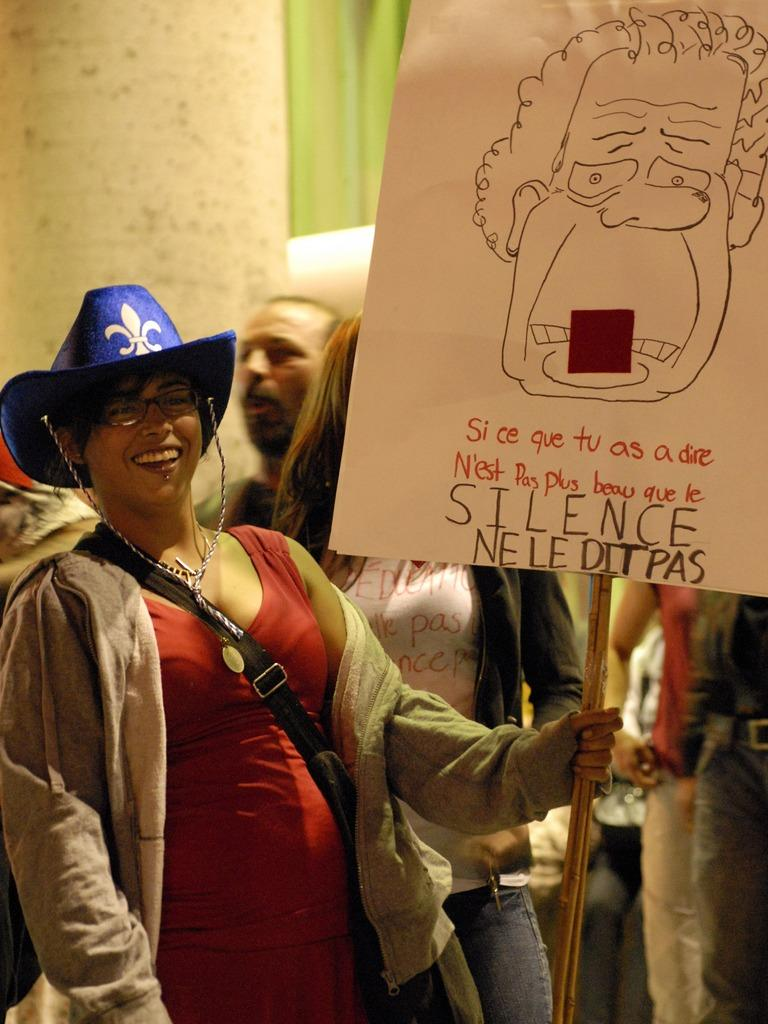How many people are in the image? There is a group of people in the image. What is the woman holding in the image? The woman is holding a banner in the image. What is the expression on the woman's face? The woman is smiling in the image. What can be seen in the background of the image? There is a wall in the background of the image. What type of yarn is the woman using to decorate the flowers in the image? There is no yarn or flowers present in the image. 